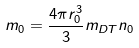Convert formula to latex. <formula><loc_0><loc_0><loc_500><loc_500>m _ { 0 } = \frac { 4 \pi r _ { 0 } ^ { 3 } } { 3 } m _ { D T } n _ { 0 }</formula> 